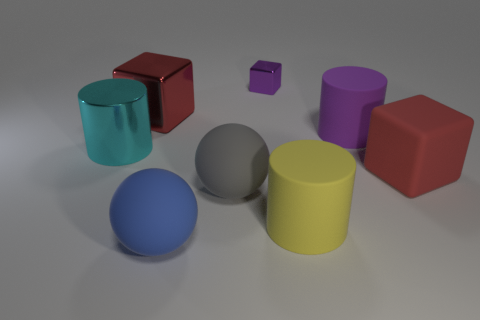What shape is the cyan metal thing that is the same size as the gray rubber thing?
Your response must be concise. Cylinder. There is a purple thing in front of the large red metallic cube; what is its shape?
Keep it short and to the point. Cylinder. Are there fewer tiny purple metallic blocks that are in front of the blue sphere than purple metallic things to the right of the tiny shiny object?
Ensure brevity in your answer.  No. Is the size of the cyan metallic cylinder the same as the purple metal cube behind the large gray sphere?
Provide a succinct answer. No. How many blue things are the same size as the red matte object?
Your answer should be compact. 1. What is the color of the tiny object that is the same material as the large cyan object?
Your answer should be compact. Purple. Are there more purple cylinders than small red blocks?
Provide a short and direct response. Yes. Are the big yellow object and the big gray sphere made of the same material?
Your answer should be very brief. Yes. There is a large red thing that is made of the same material as the gray object; what shape is it?
Your response must be concise. Cube. Are there fewer cyan metal objects than large green cubes?
Provide a short and direct response. No. 